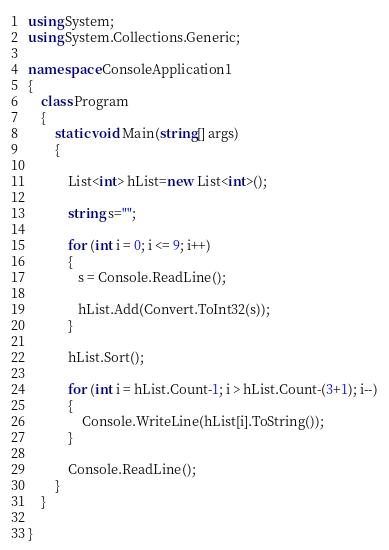Convert code to text. <code><loc_0><loc_0><loc_500><loc_500><_C#_>using System;
using System.Collections.Generic;

namespace ConsoleApplication1
{
    class Program
    {
        static void Main(string[] args)
        {

            List<int> hList=new List<int>();

            string s="";

            for (int i = 0; i <= 9; i++)
            {
               s = Console.ReadLine();

               hList.Add(Convert.ToInt32(s));
            }

            hList.Sort();

            for (int i = hList.Count-1; i > hList.Count-(3+1); i--)
            {
                Console.WriteLine(hList[i].ToString());
            }

            Console.ReadLine(); 
        }
    }

}</code> 